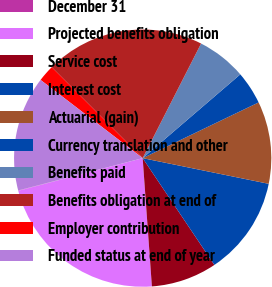Convert chart to OTSL. <chart><loc_0><loc_0><loc_500><loc_500><pie_chart><fcel>December 31<fcel>Projected benefits obligation<fcel>Service cost<fcel>Interest cost<fcel>Actuarial (gain)<fcel>Currency translation and other<fcel>Benefits paid<fcel>Benefits obligation at end of<fcel>Employer contribution<fcel>Funded status at end of year<nl><fcel>0.04%<fcel>22.06%<fcel>8.27%<fcel>12.39%<fcel>10.33%<fcel>4.16%<fcel>6.21%<fcel>20.0%<fcel>2.1%<fcel>14.45%<nl></chart> 